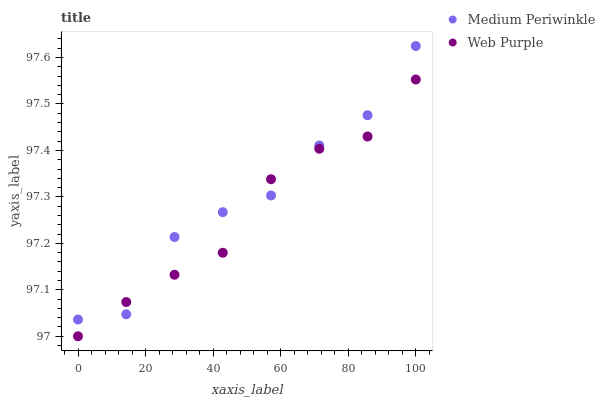Does Web Purple have the minimum area under the curve?
Answer yes or no. Yes. Does Medium Periwinkle have the maximum area under the curve?
Answer yes or no. Yes. Does Medium Periwinkle have the minimum area under the curve?
Answer yes or no. No. Is Web Purple the smoothest?
Answer yes or no. Yes. Is Medium Periwinkle the roughest?
Answer yes or no. Yes. Is Medium Periwinkle the smoothest?
Answer yes or no. No. Does Web Purple have the lowest value?
Answer yes or no. Yes. Does Medium Periwinkle have the lowest value?
Answer yes or no. No. Does Medium Periwinkle have the highest value?
Answer yes or no. Yes. Does Web Purple intersect Medium Periwinkle?
Answer yes or no. Yes. Is Web Purple less than Medium Periwinkle?
Answer yes or no. No. Is Web Purple greater than Medium Periwinkle?
Answer yes or no. No. 